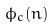Convert formula to latex. <formula><loc_0><loc_0><loc_500><loc_500>\phi _ { c } ( n )</formula> 